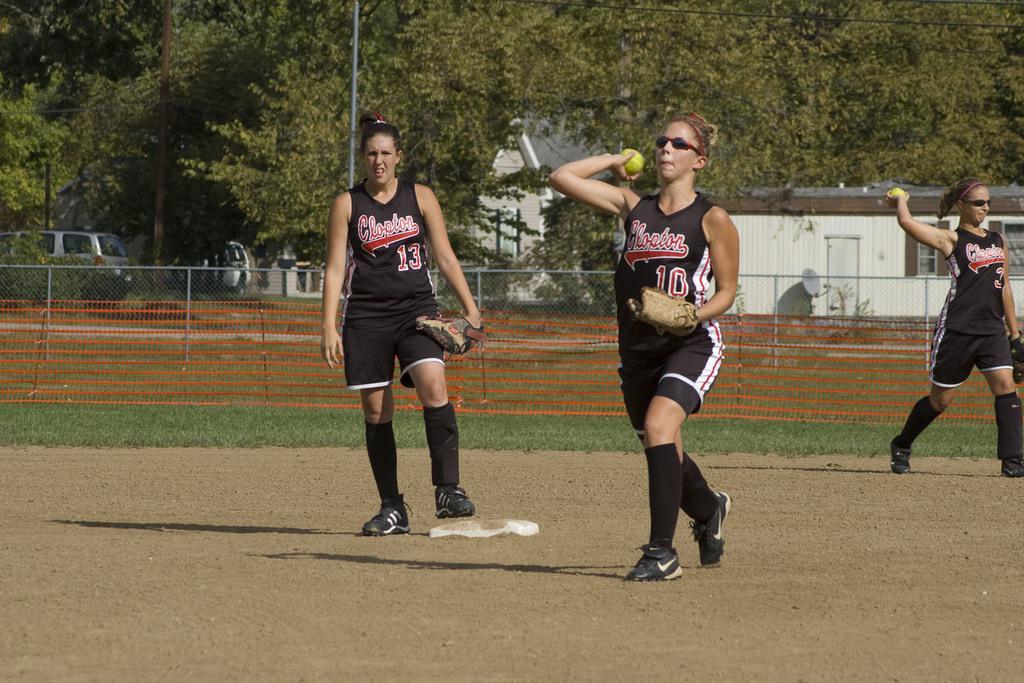How would you summarize this image in a sentence or two? This picture is clicked outside. On the left there is a woman wearing black color t-shirt and walking on the ground. On the right we can see the two persons wearing black color t-shirts, gloves, holding balls and seems to be walking on the ground. In the background we can see the green grass, net, metal rods, vehicles, trees and some houses. 